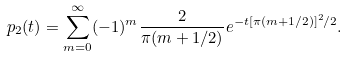<formula> <loc_0><loc_0><loc_500><loc_500>p _ { 2 } ( t ) = \sum _ { m = 0 } ^ { \infty } ( - 1 ) ^ { m } \frac { 2 } { \pi ( m + 1 / 2 ) } e ^ { - t [ \pi ( m + 1 / 2 ) ] ^ { 2 } / 2 } .</formula> 